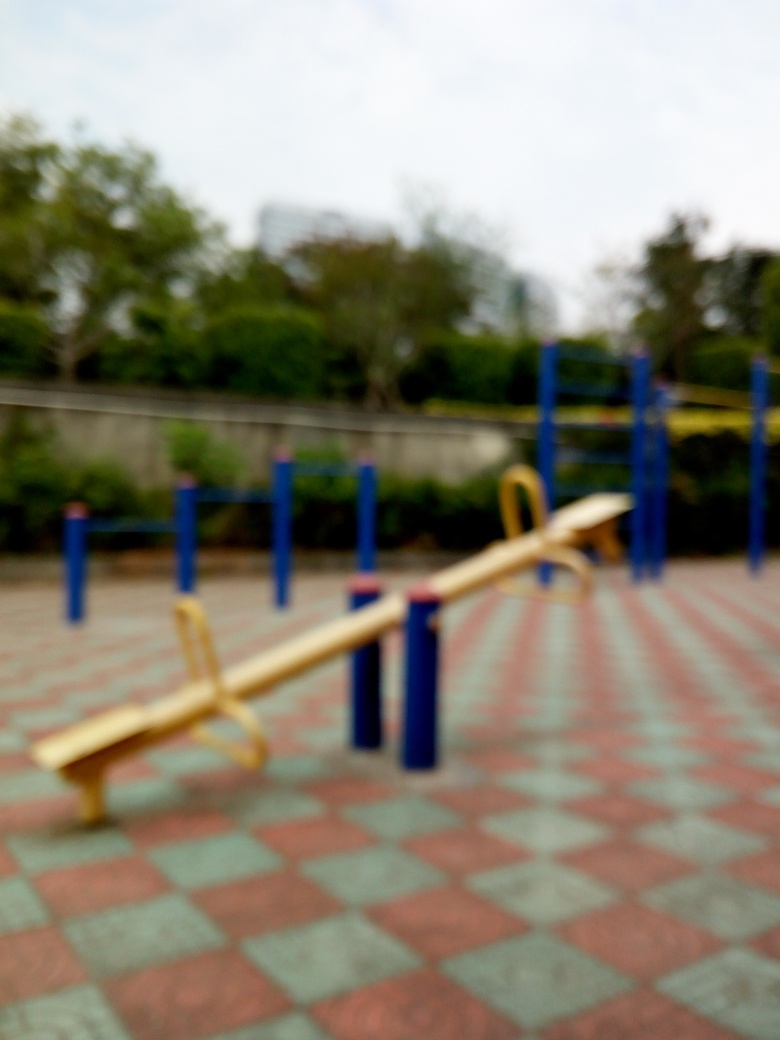What materials are typically used to make a seesaw like the one in the picture? Seesaws like the one depicted are commonly made from durable materials suitable for outdoor use, such as metal for the support structure, providing strength and stability, and plastic for the seats, ensuring a smooth and comfortable surface for seating. These materials are selected for their durability, weather resistance, and safety for children's play equipment. 